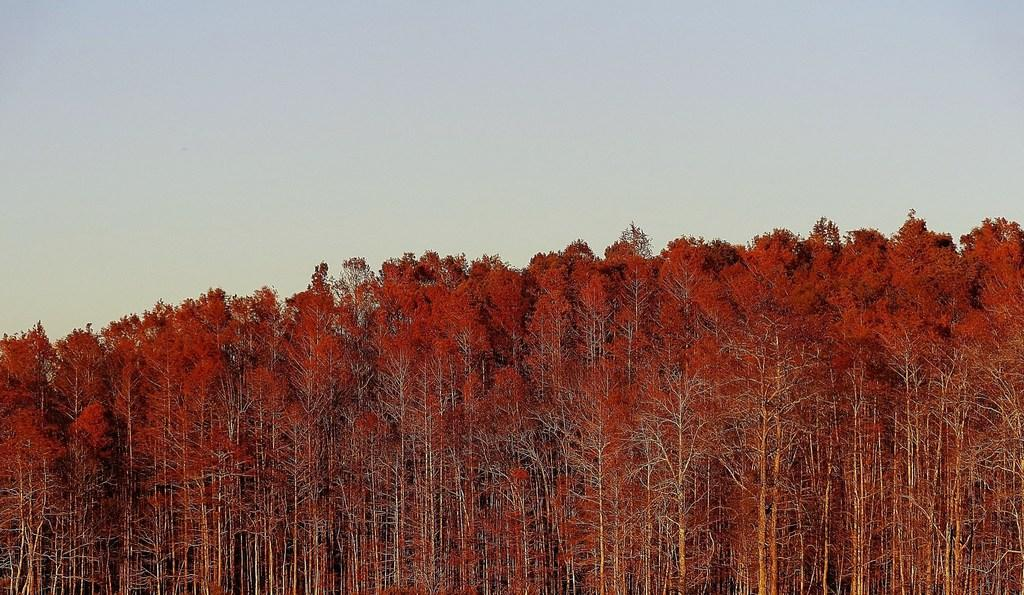What type of vegetation is present at the bottom of the picture? There are trees at the bottom of the picture. What is the color of the trees in the image? The trees are red in color. What can be seen at the top of the picture? The sky is visible at the top of the picture. What is the average income of the people living near these red trees in the image? There is no information about people or their income in the image, as it only features red trees and the sky. 